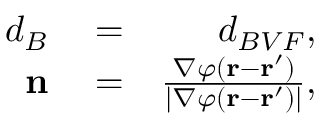Convert formula to latex. <formula><loc_0><loc_0><loc_500><loc_500>\begin{array} { r l r } { d _ { B } } & = } & { d _ { B V F } , } \\ { n } & = } & { \frac { \nabla \varphi ( r - r ^ { \prime } ) } { | \nabla \varphi ( r - r ^ { \prime } ) | } , } \end{array}</formula> 